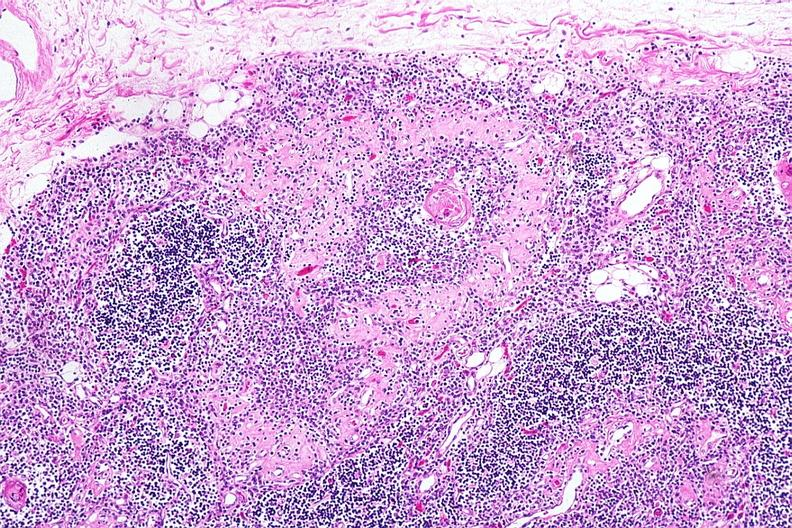what is present?
Answer the question using a single word or phrase. Follicular fibrosis suggesting previous viral infection 